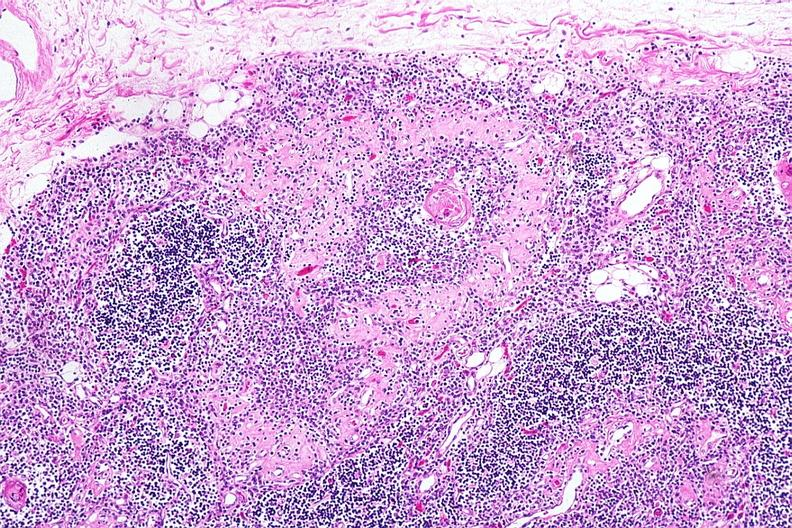what is present?
Answer the question using a single word or phrase. Follicular fibrosis suggesting previous viral infection 